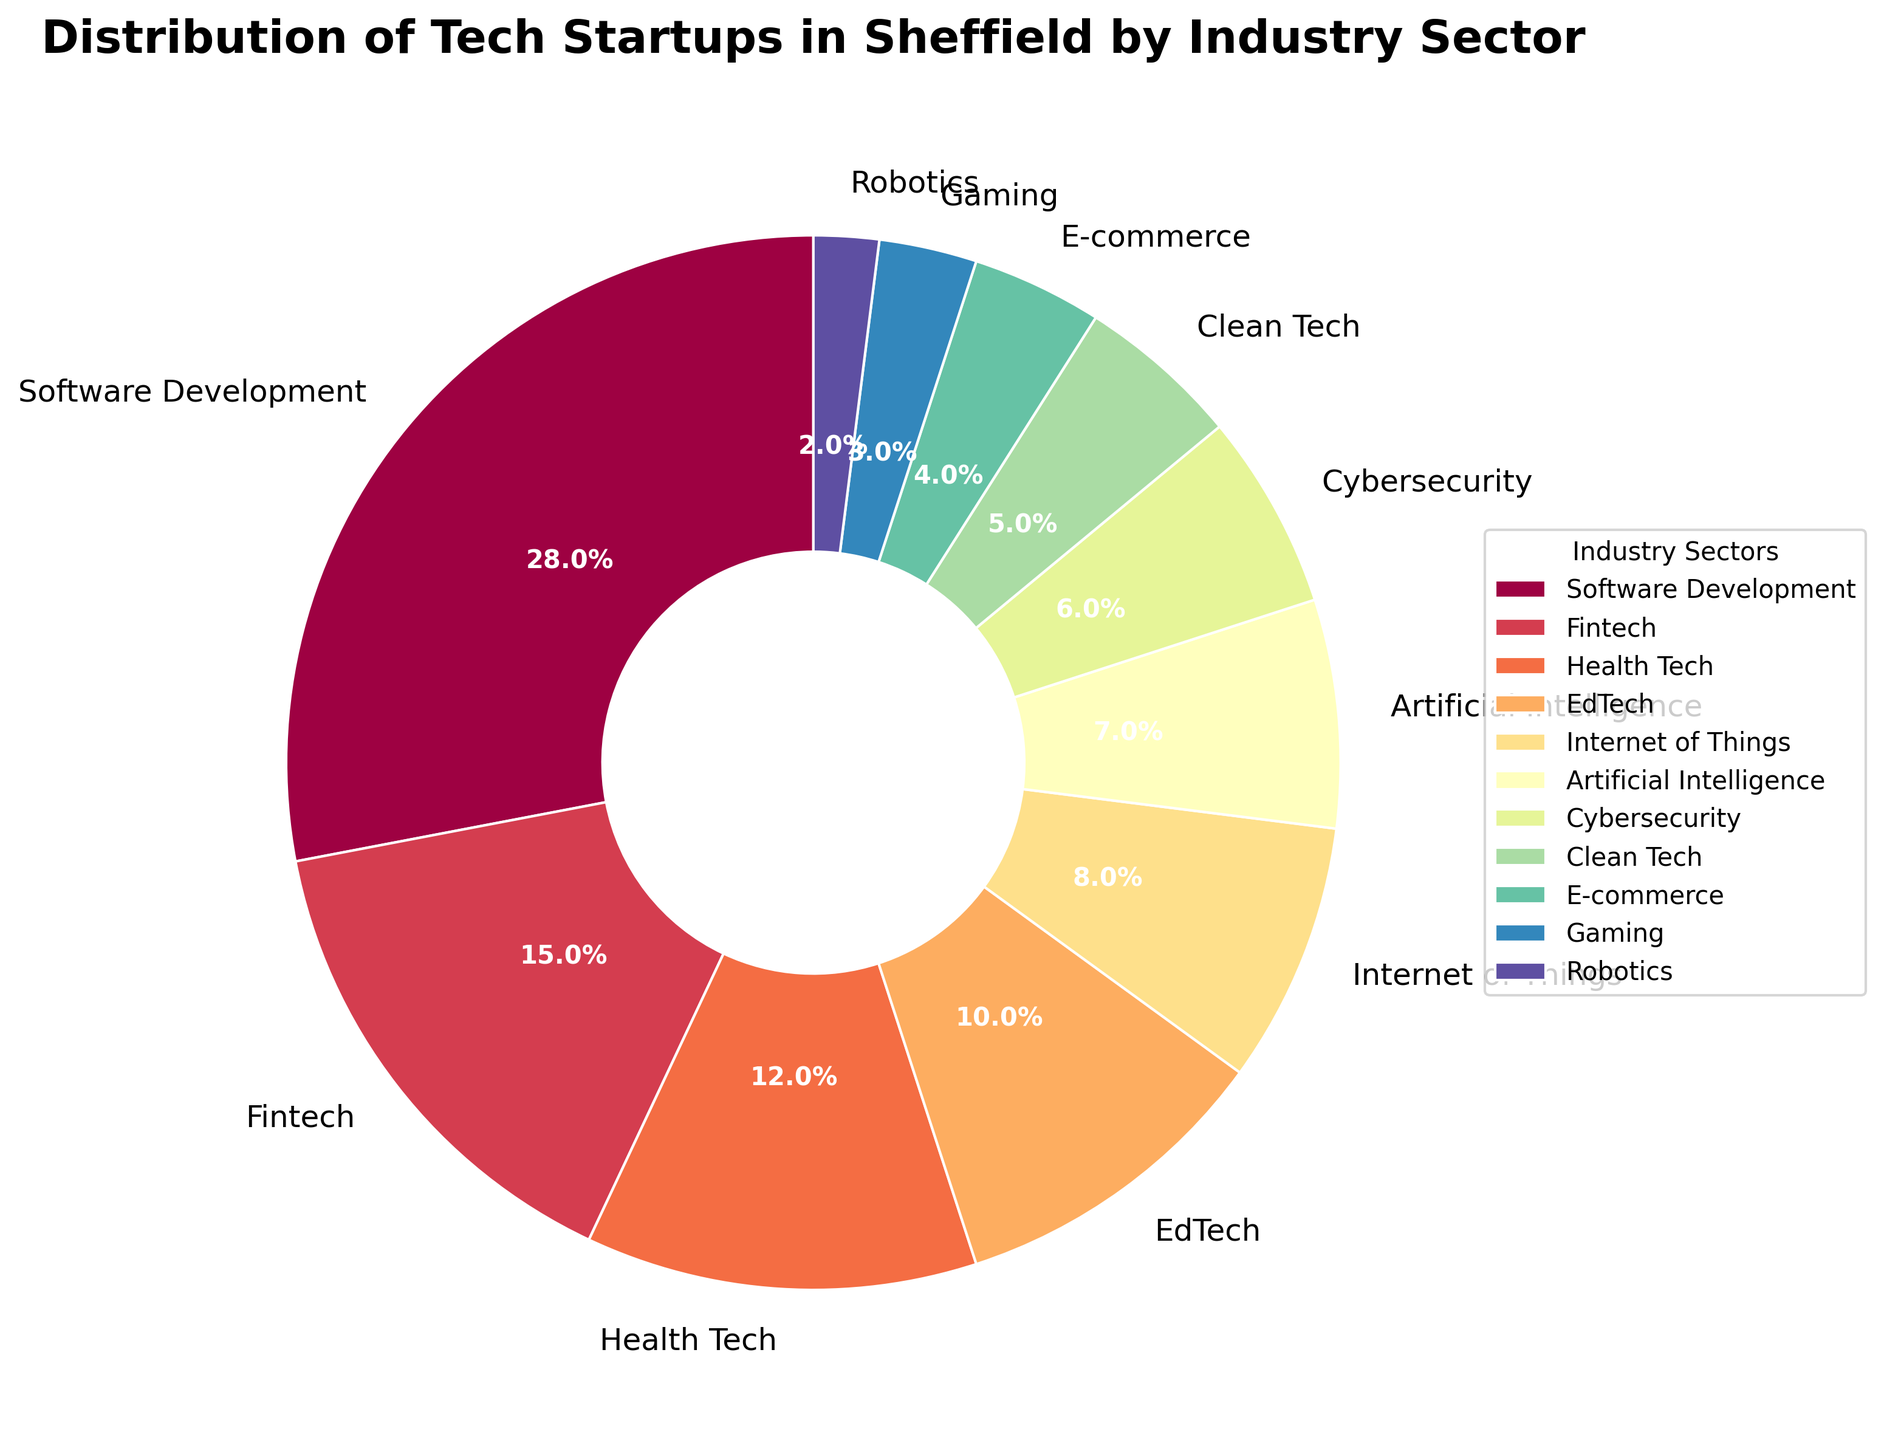What is the largest industry sector for tech startups in Sheffield? The pie chart shows that the largest sector is represented by the largest wedge, which is labeled "Software Development" with 28%.
Answer: Software Development Which industry sectors have a percentage greater than or equal to 10%? By visually scanning the percentages labeled on the chart, we can see that "Software Development" (28%), "Fintech" (15%), "Health Tech" (12%), and "EdTech" (10%) are sectors with percentages greater than or equal to 10%.
Answer: Software Development, Fintech, Health Tech, EdTech What is the combined percentage of the Fintech and Internet of Things sectors? To find the combined percentage, add the individual percentages of "Fintech" (15%) and "Internet of Things" (8%). This gives us a total of 15% + 8% = 23%.
Answer: 23% How much larger is the Health Tech sector compared to Cybersecurity? The Health Tech sector is 12%, and the Cybersecurity sector is 6%. Subtracting, we get 12% - 6% = 6%.
Answer: 6% Which two sectors have the smallest representation, and what are their combined percentages? The two smallest sectors in the chart are "Gaming" (3%) and "Robotics" (2%). Adding these together gives us 3% + 2% = 5%.
Answer: Gaming and Robotics, 5% Which industry sectors are smaller than 10% but larger than 5%? By visually examining the labeled wedges, the sectors fitting this criterion are "Internet of Things" (8%), "Artificial Intelligence" (7%), and "Cybersecurity" (6%).
Answer: Internet of Things, Artificial Intelligence, Cybersecurity What percentage of tech startups are in the Clean Tech and E-commerce sectors combined? The chart shows that "Clean Tech" is 5% and "E-commerce" is 4%. Adding these together gives us 5% + 4% = 9%.
Answer: 9% How does the size of the wedge for Fintech compare to that of Clean Tech? By looking at the chart, the wedge for Fintech (15%) is larger than that for Clean Tech (5%). Specifically, it is three times larger (15% / 5% = 3).
Answer: Fintech is three times larger 